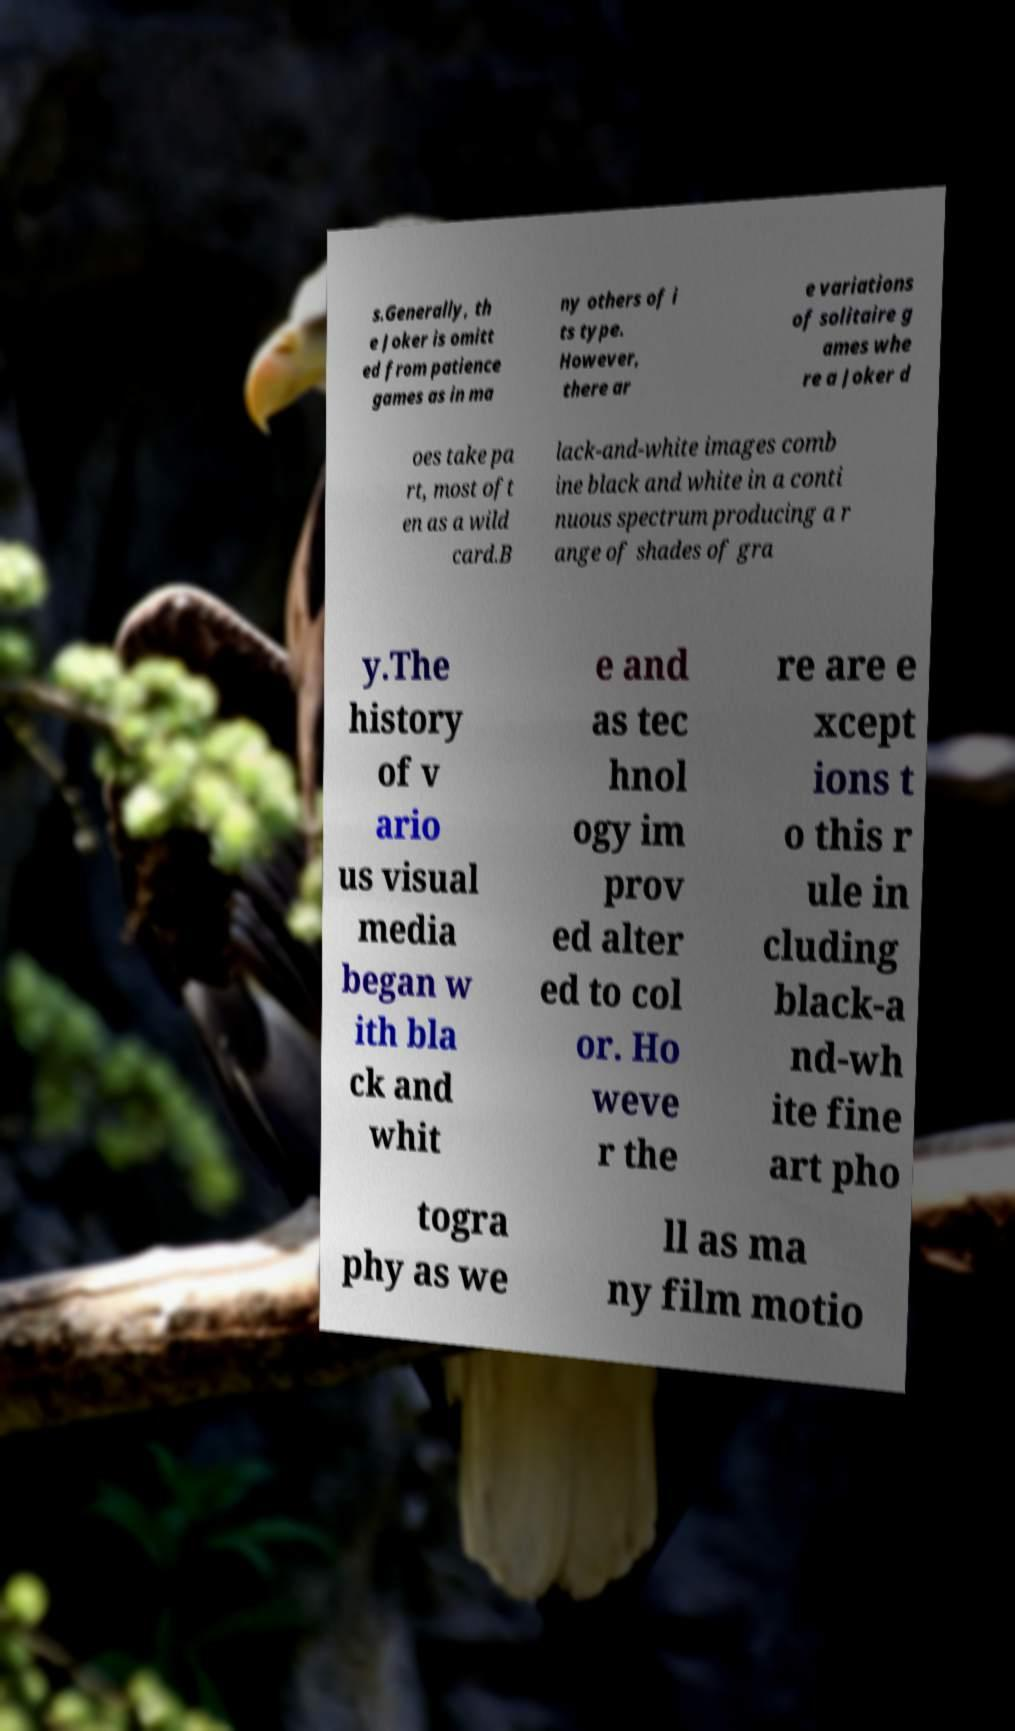What messages or text are displayed in this image? I need them in a readable, typed format. s.Generally, th e Joker is omitt ed from patience games as in ma ny others of i ts type. However, there ar e variations of solitaire g ames whe re a Joker d oes take pa rt, most oft en as a wild card.B lack-and-white images comb ine black and white in a conti nuous spectrum producing a r ange of shades of gra y.The history of v ario us visual media began w ith bla ck and whit e and as tec hnol ogy im prov ed alter ed to col or. Ho weve r the re are e xcept ions t o this r ule in cluding black-a nd-wh ite fine art pho togra phy as we ll as ma ny film motio 